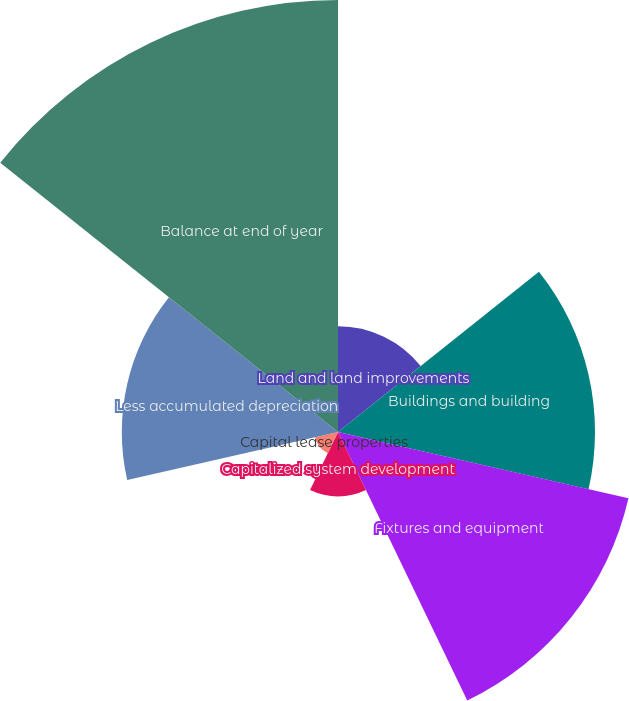<chart> <loc_0><loc_0><loc_500><loc_500><pie_chart><fcel>Land and land improvements<fcel>Buildings and building<fcel>Fixtures and equipment<fcel>Capitalized system development<fcel>Capital lease properties<fcel>Less accumulated depreciation<fcel>Balance at end of year<nl><fcel>7.57%<fcel>18.4%<fcel>21.33%<fcel>4.61%<fcel>1.69%<fcel>15.48%<fcel>30.93%<nl></chart> 